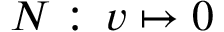<formula> <loc_0><loc_0><loc_500><loc_500>N \colon \, v \mapsto 0</formula> 